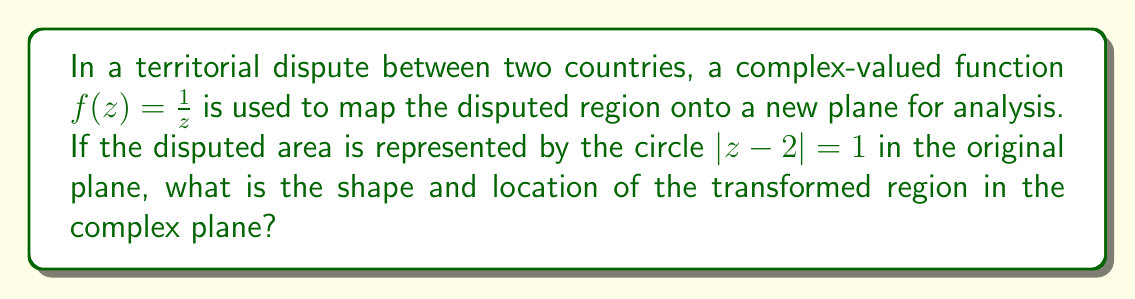Solve this math problem. To solve this problem, we'll follow these steps:

1) The given function $f(z) = \frac{1}{z}$ is a conformal mapping known as the inversion map.

2) The original region is a circle with center at $z = 2$ and radius 1.

3) To find the image of this circle under the inversion map, we use the following property:
   The image of a circle under inversion is either a circle or a line.

4) Specifically, if the original circle passes through the origin, its image will be a line. If not, it will be another circle.

5) In this case, the circle $|z-2| = 1$ does not pass through the origin, so its image will be a circle.

6) For a circle $|z-a| = r$ that doesn't pass through the origin, its image under $f(z) = \frac{1}{z}$ is a circle with center $\frac{\overline{a}}{|a|^2 - r^2}$ and radius $\frac{r}{||a|^2 - r^2|}$.

7) In our case, $a = 2$ and $r = 1$. So:
   
   Center = $\frac{\overline{2}}{|2|^2 - 1^2} = \frac{2}{4-1} = \frac{2}{3}$
   
   Radius = $\frac{1}{|2|^2 - 1^2} = \frac{1}{4-1} = \frac{1}{3}$

8) Therefore, the image of the original circle under the mapping $f(z) = \frac{1}{z}$ is a circle with center at $\frac{2}{3}$ and radius $\frac{1}{3}$.
Answer: A circle centered at $\frac{2}{3}$ with radius $\frac{1}{3}$. 